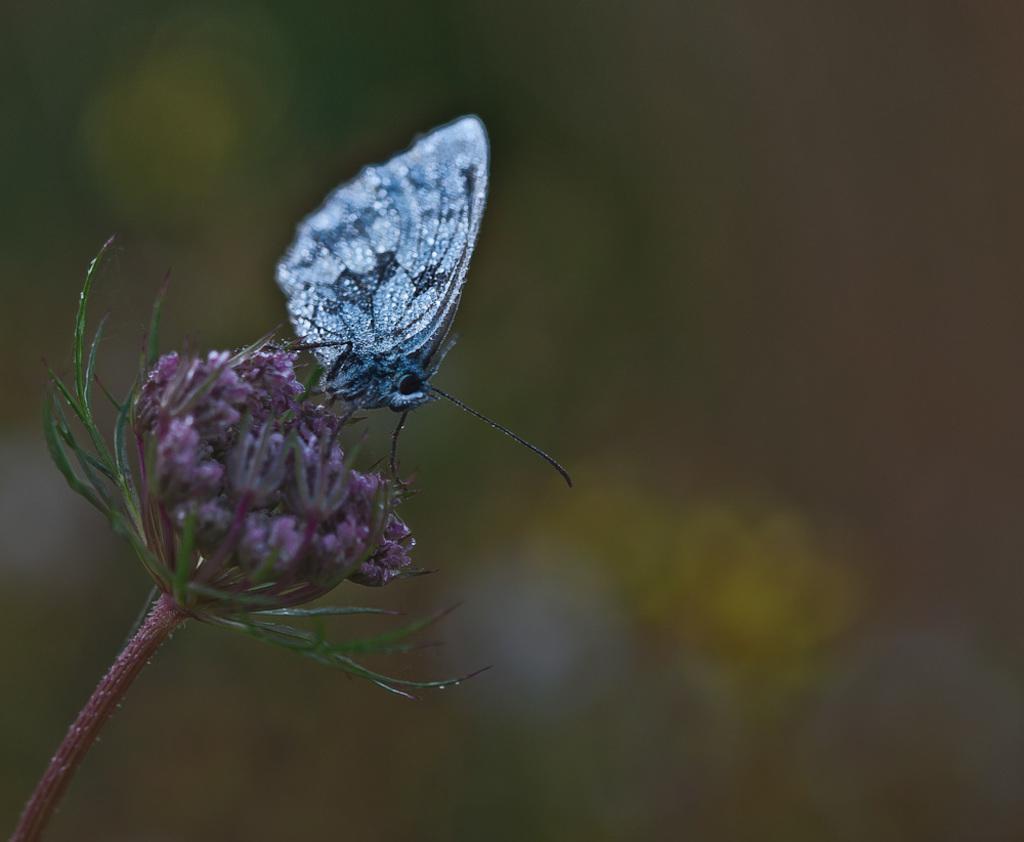Can you describe this image briefly? In the image in the center we can see one flower. On the flower,we can see one silver color butterfly. 